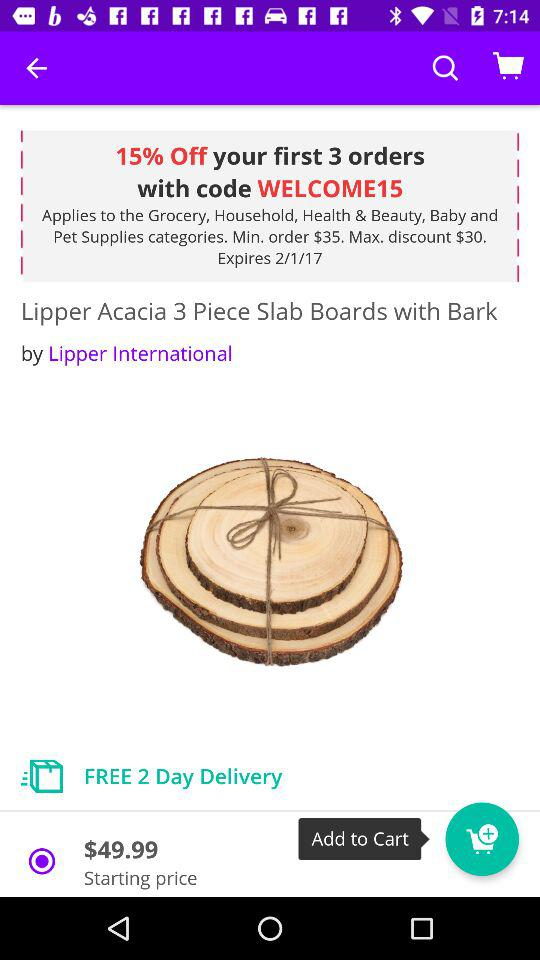What is the product name for which the starting price is $49.99? The product name is "Lipper Acacia 3 Piece Slab Boards with Bark". 